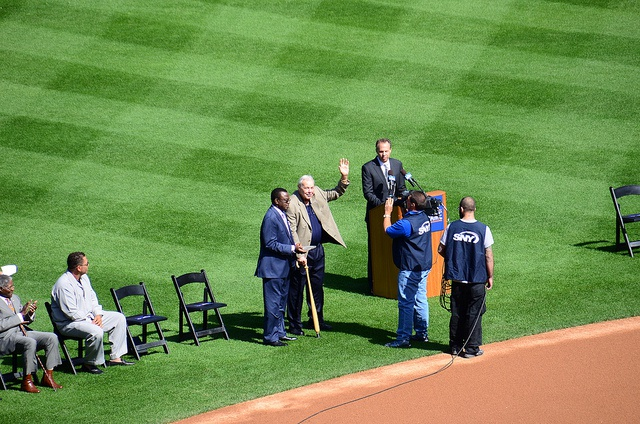Describe the objects in this image and their specific colors. I can see people in darkgreen, black, navy, darkblue, and lavender tones, people in darkgreen, black, lightgray, tan, and darkgray tones, people in darkgreen, black, navy, blue, and darkblue tones, people in darkgreen, lavender, black, darkgray, and gray tones, and people in darkgreen, black, navy, blue, and darkblue tones in this image. 